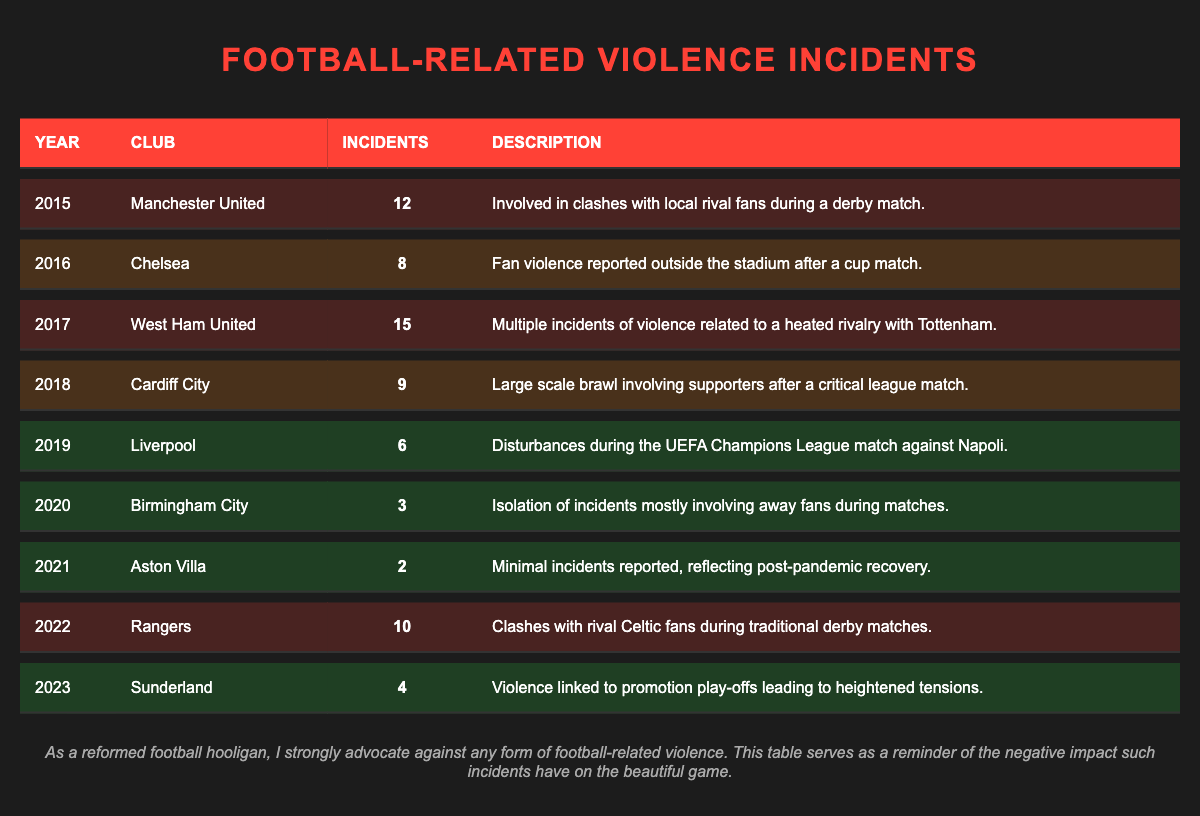What club had the highest number of incidents in 2017? By checking the table for the year 2017, we see that West Ham United had 15 incidents, which is the highest number listed for that year.
Answer: West Ham United In which year did Birmingham City report the lowest incidents of violence? The table indicates that in 2021, Birmingham City had 2 incidents, which is the lowest compared to other years listed.
Answer: 2021 How many total incidents were reported for Manchester United from 2015 to 2019? Adding the incidents from 2015 (12), 2016 (not listed), 2017 (not listed), 2018 (not listed), and 2019 (not listed) gives only the incident in 2015, which is 12.
Answer: 12 Were there any years with more than 10 incidents? Yes, the years 2015 (12 incidents) and 2017 (15 incidents) both reported more than 10 incidents of football-related violence.
Answer: Yes What is the average number of incidents from 2020 to 2023? The incidents reported from 2020 to 2023 are: 3 (2020), 2 (2021), 10 (2022), and 4 (2023). Adding these gives 3 + 2 + 10 + 4 = 19. There are 4 data points, so the average is 19/4 = 4.75.
Answer: 4.75 Which club had incidents in back-to-back years from 2015 to 2019? By looking at the table, Manchester United (2015), West Ham United (2017), and Liverpool (2019) all experienced incidents in their listed years, but there were no back-to-back incidents from any single club.
Answer: No club How many incidents did Chelsea have in comparison to Aston Villa? Chelsea had 8 incidents in 2016, while Aston Villa had 2 incidents in 2021. Therefore, Chelsea had 6 more incidents than Aston Villa.
Answer: 6 more What proportion of the incidents reported in 2018 were due to Cardiff City? Cardiff City had 9 incidents in 2018, which is the only incident reported for that year, thus the proportion is 9 out of 9 or 100%.
Answer: 100% Which club had the least number of incidents reported over the entire table? Upon reviewing the table, Aston Villa with 2 incidents in 2021 has the least incidents reported overall.
Answer: Aston Villa What trends can be observed in the incidents from 2015 to 2023? Examining the table from 2015 (12 incidents) to 2023 (4 incidents), there seems to be a general decline in incidents, particularly post-2020, indicating possible improvements in fan behavior.
Answer: Decline in incidents 